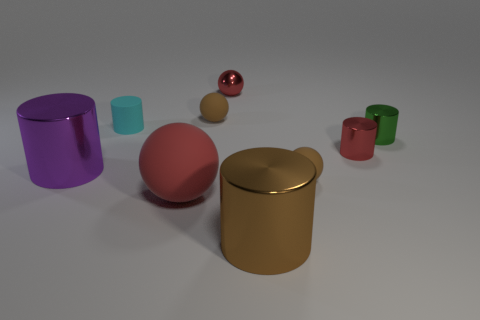Can you identify the shapes of objects in the image? Certainly. The image contains a variety of geometric shapes, including cylinders, spheres, and a cube. These shapes vary in size and color, giving the scene visual interest and diversity. 